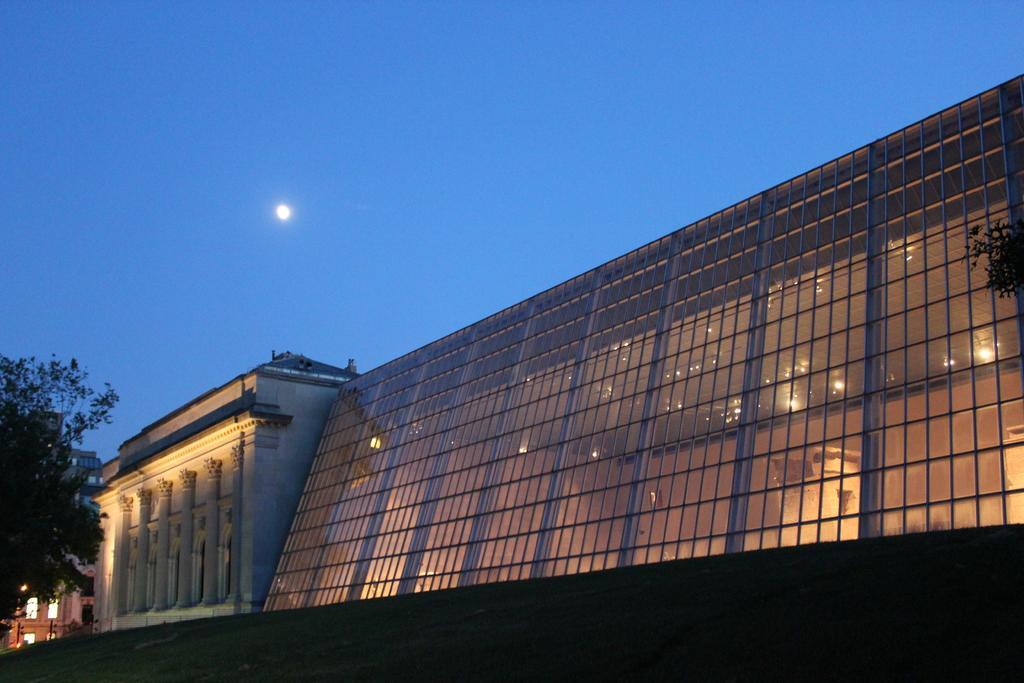Could you give a brief overview of what you see in this image? In this image we can see a group of buildings, trees, poles and in the background we can see the sky. 